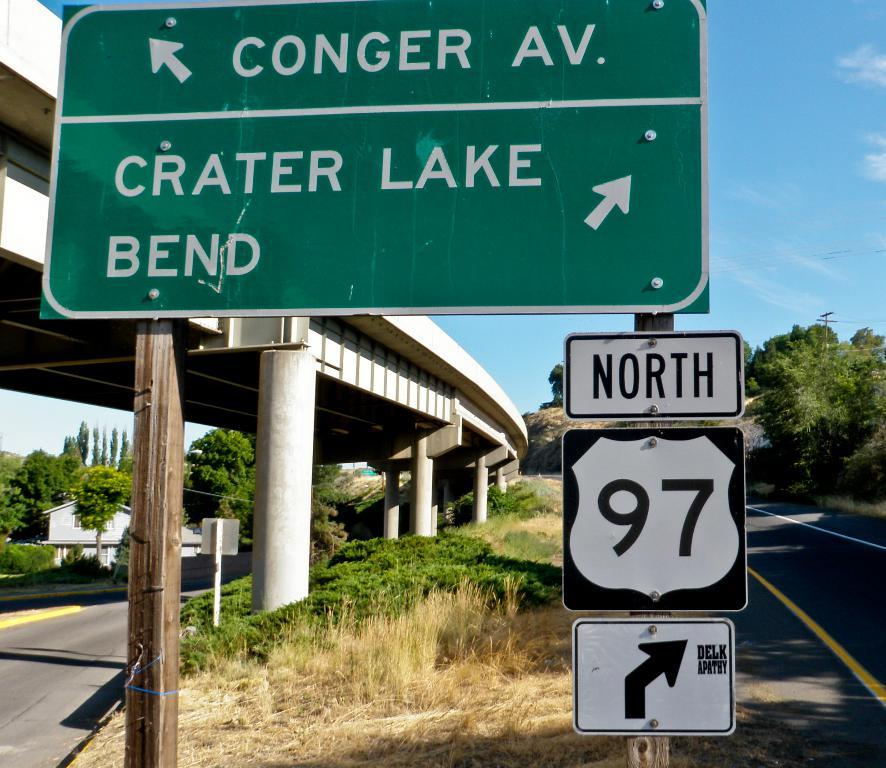<image>
Render a clear and concise summary of the photo. A road sign that shows that North Highway 97 is to the right. 